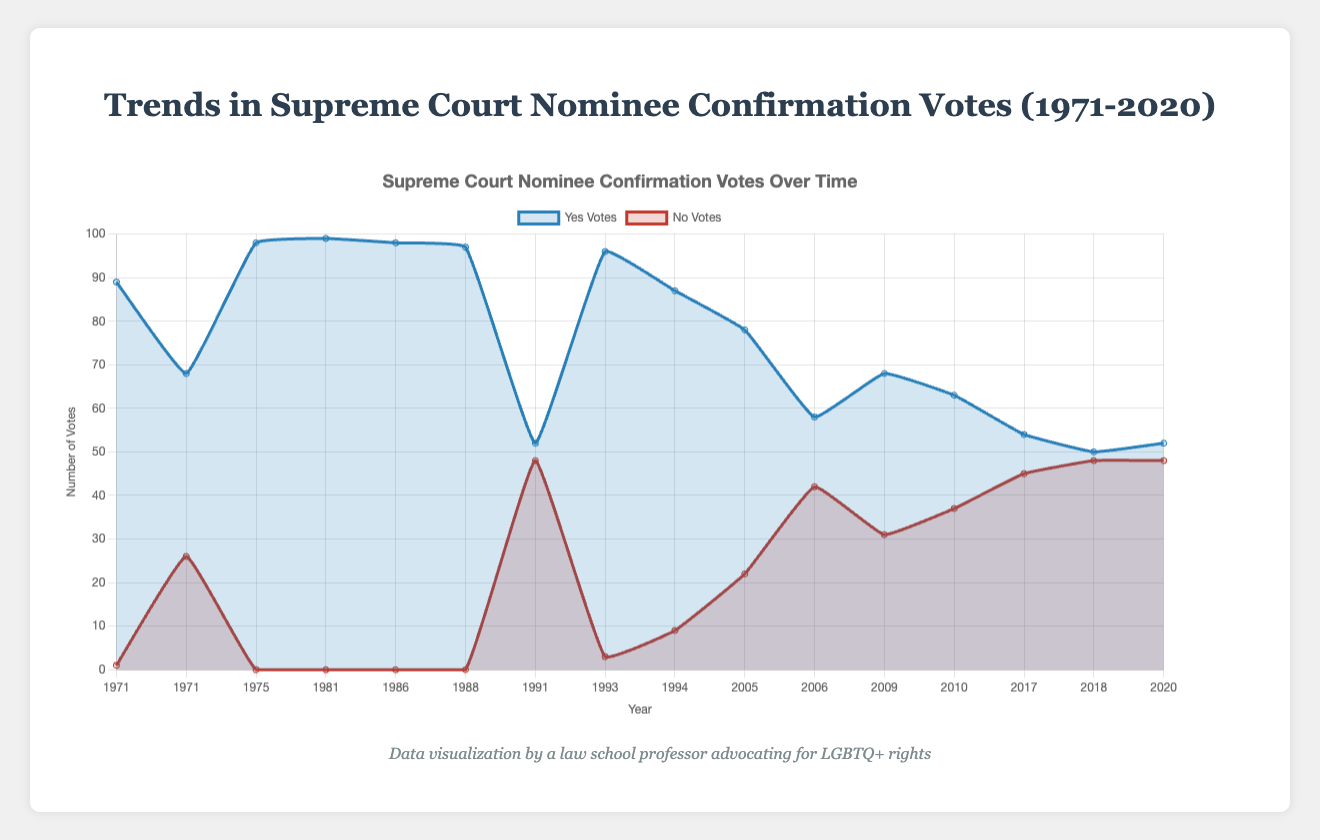When did the figure show the closest number of 'Yes' and 'No' votes for a Supreme Court nominee? Observe the plot where the 'Yes' and 'No' vote lines intersect or are very close to each other. This occurs in 1991 for Clarence Thomas (52 Yes and 48 No) and in 2018 for Brett Kavanaugh (50 Yes and 48 No). Both instances show that 'Yes' and 'No' votes are very close.
Answer: 1991 and 2018 Which nominee had the highest number of 'Yes' votes, and in what year did that occur? Identify the highest peak on the 'Yes' votes line plot. The highest number of 'Yes' votes is 99, which was for Sandra Day O'Connor in 1981.
Answer: Sandra Day O'Connor, 1981 Between 1988 and 1993, how did the number of 'Yes' votes change? Compare the 'Yes' votes values between these years: Anthony Kennedy in 1988 has 97 Yes votes, and Ruth Bader Ginsburg in 1993 has 96 Yes votes. The number of 'Yes' votes decreased by 1.
Answer: Decreased by 1 What can we infer about the general trend in 'No' votes from 1971 to 2020? Visualize the trajectory of the 'No' votes line. Initially, the values are very low or zero but increase significantly in later years. This indicates that 'No' votes have become more common over time.
Answer: 'No' votes have generally increased For which nominee did the 'No' votes first exceed 40? Look at the 'No' votes line and identify the first point where it crosses the 40 mark. Samuel Alito in 2006 had 42 No votes.
Answer: Samuel Alito How many nominees received unanimous 'Yes' votes, and who are they? Identify the points where 'No' votes are zero. This occurs for John Paul Stevens (1975), Sandra Day O'Connor (1981), Antonin Scalia (1986), and Anthony Kennedy (1988). Count these instances.
Answer: Four nominees (John Paul Stevens, Sandra Day O'Connor, Antonin Scalia, Anthony Kennedy) What is the average number of 'Yes' votes for the nominees after the year 2000? Sum the 'Yes' votes for nominees from 2005 onwards: John Roberts (78) + Samuel Alito (58) + Sonia Sotomayor (68) + Elena Kagan (63) + Neil Gorsuch (54) + Brett Kavanaugh (50) + Amy Coney Barrett (52). Then, divide by the number of nominees (7). The sum is 423, and the average is 423/7.
Answer: 60.43 Which year shows the largest difference between 'Yes' and 'No' votes, and what is the difference? Calculate the difference between 'Yes' and 'No' votes for each year. The largest difference is for Sandra Day O'Connor in 1981 with 99 Yes votes and 0 No votes, a difference of 99.
Answer: 1981, 99 What indicates that the confirmation vote process has become more polarized over the years? Examine the range between 'Yes' and 'No' votes. Initially, the range is broad with high 'Yes' and low or zero 'No' votes, but recent years show a narrowing range, indicating close and contentious votes.
Answer: Increase in 'No' votes and narrowing margin How many nominees in the plot had at least 30 'No' votes? Count the instances in the 'No' votes line where the value is 30 or higher. This happens for William Rehnquist (1971; 26 is close but under 30), Samuel Alito (2006; 42), Sonia Sotomayor (2009; 31), Elena Kagan (2010; 37), Neil Gorsuch (2017; 45), Brett Kavanaugh (2018; 48), and Amy Coney Barrett (2020; 48). Count these nominees.
Answer: Five nominees (Samuel Alito, Sonia Sotomayor, Elena Kagan, Neil Gorsuch, Brett Kavanaugh, Amy Coney Barrett) 